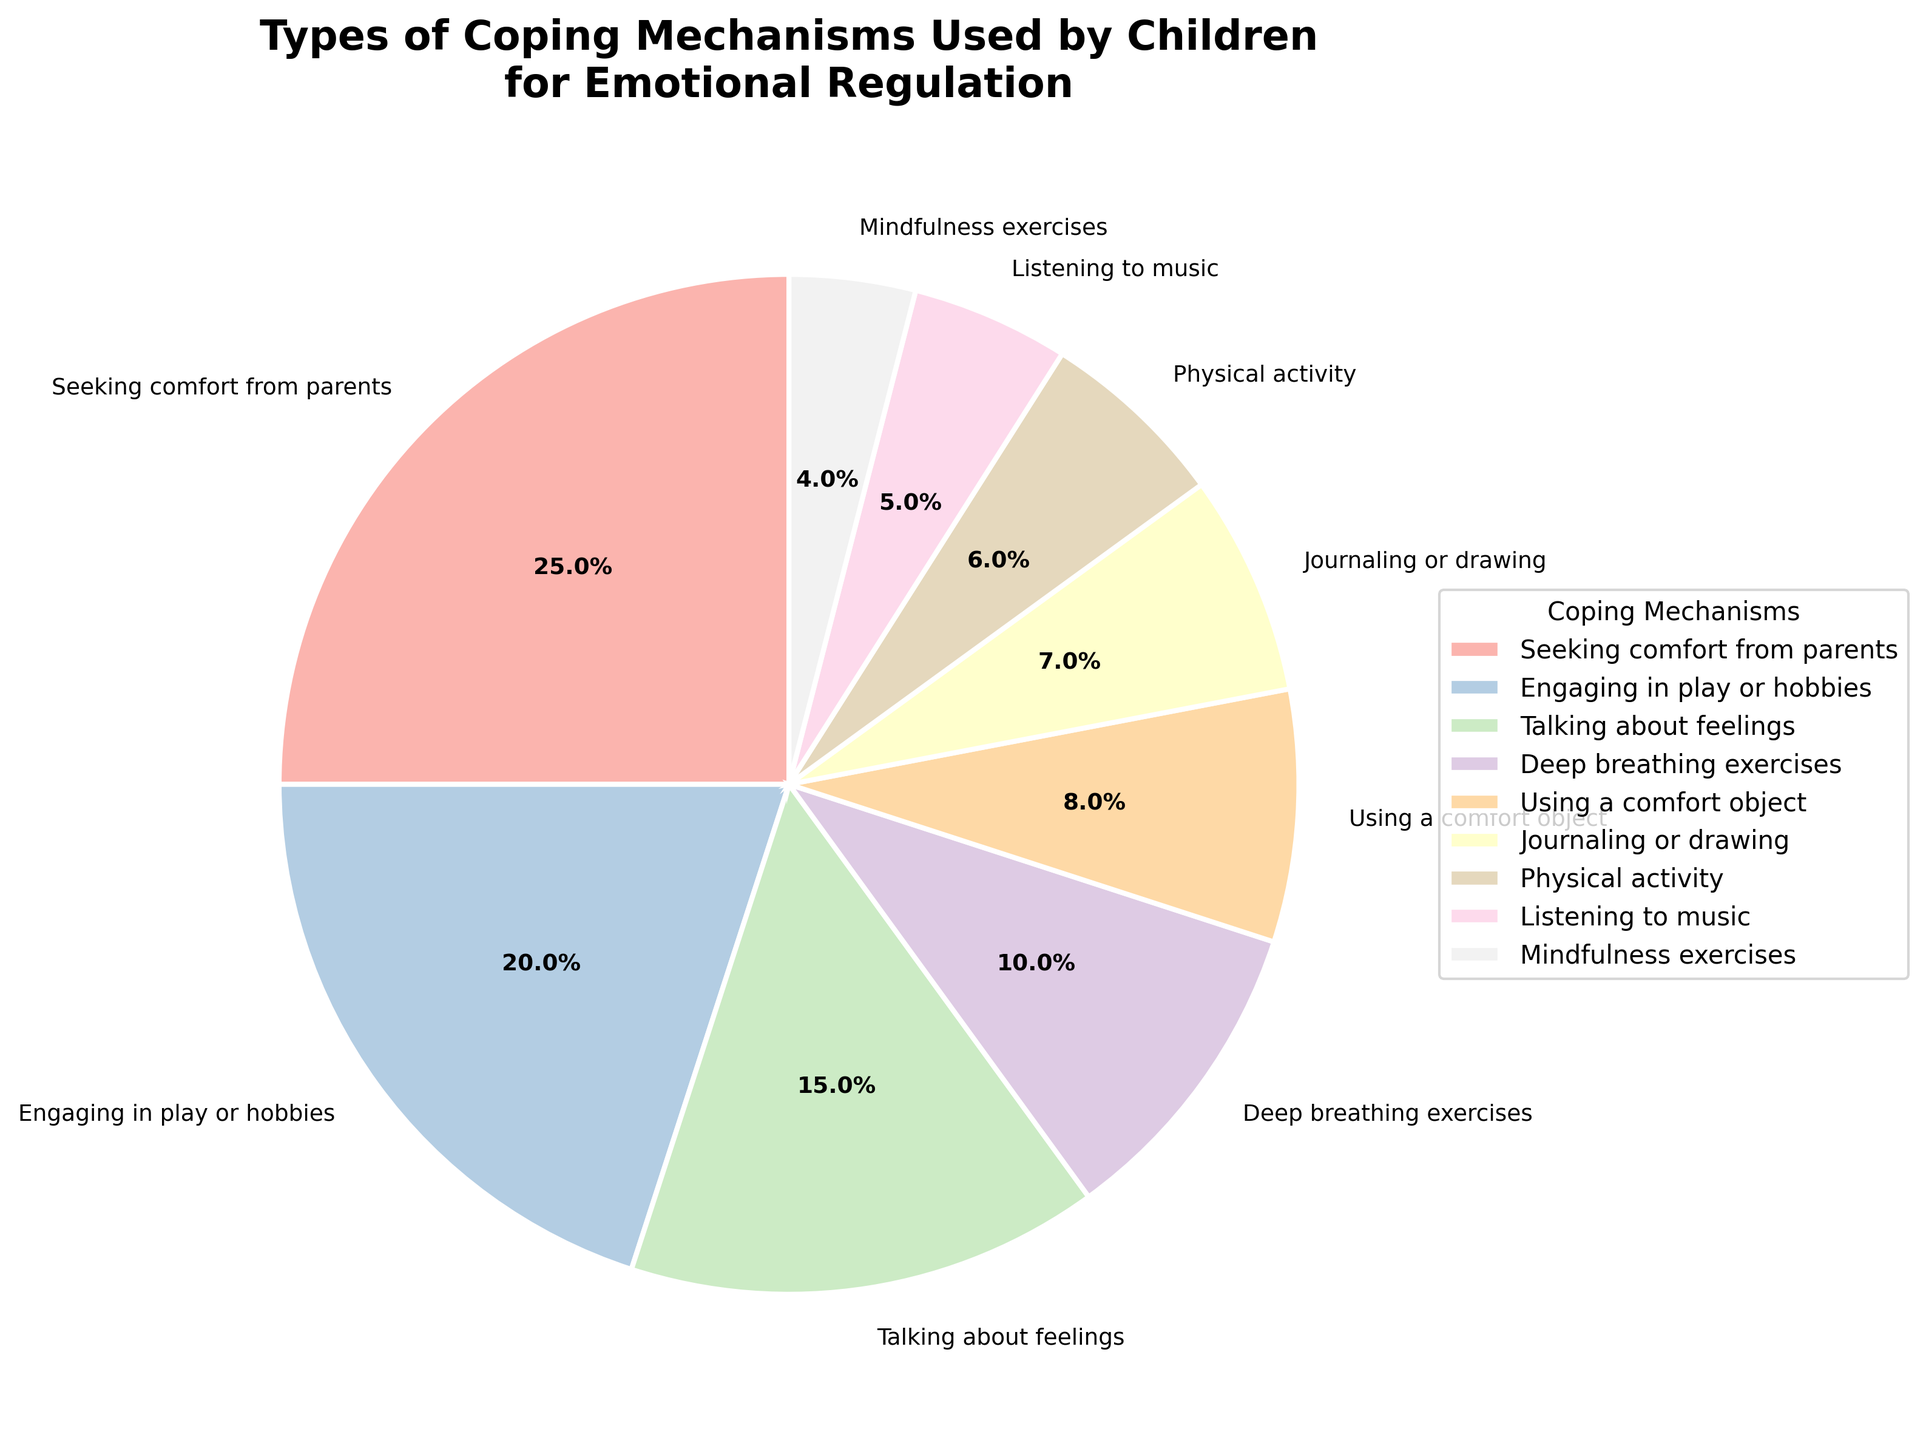Which coping mechanism is used by the highest percentage of children? The largest wedge in the pie chart represents "Seeking comfort from parents" at 25%.
Answer: Seeking comfort from parents How much more common is "Engaging in play or hobbies" compared to "Using a comfort object"? "Engaging in play or hobbies" is 20%, and "Using a comfort object" is 8%. The difference is 20% - 8% = 12%.
Answer: 12% Which coping mechanism is used by the least percentage of children? The smallest wedge in the pie chart represents "Mindfulness exercises" at 4%.
Answer: Mindfulness exercises What is the combined percentage of children who use "Talking about feelings" and "Deep breathing exercises"? "Talking about feelings" is 15%, and "Deep breathing exercises" is 10%. Their combined percentage is 15% + 10% = 25%.
Answer: 25% Is "Physical activity" used by more children than "Listening to music"? "Physical activity" is used by 6%, while "Listening to music" is used by 5%. Therefore, "Physical activity" is used by more children.
Answer: Yes Which two coping mechanisms have percentages that add up to 30%? "Engaging in play or hobbies" is 20%, and "Talking about feelings" is 15%. Summing these up, we get 20% + 15% = 35%. The pair that sums to 30% is "Engaging in play or hobbies" (20%) and "Deep breathing exercises" (10%).
Answer: Engaging in play or hobbies and Deep breathing exercises How does the percentage of children using "Journaling or drawing" compare to those using "Mindfulness exercises"? "Journaling or drawing" is used by 7%, while "Mindfulness exercises" is used by 4%, so 7% is greater than 4%.
Answer: Greater than What is the total percentage of children using either "Using a comfort object" or "Listening to music"? "Using a comfort object" is 8%, and "Listening to music" is 5%. Their total is 8% + 5% = 13%.
Answer: 13% What is the approximate average percentage of the top three coping mechanisms? The top three coping mechanisms by percentages are "Seeking comfort from parents" (25%), "Engaging in play or hobbies" (20%), and "Talking about feelings" (15%). The average is (25% + 20% + 15%) / 3 = 60% / 3 = 20%.
Answer: 20% 